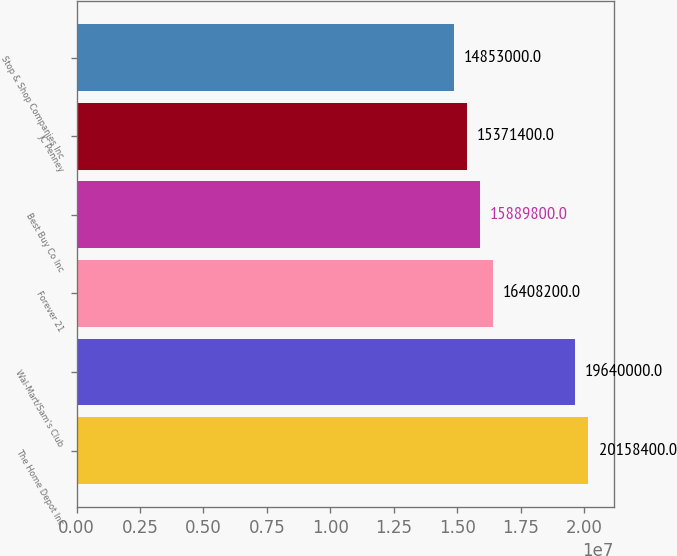<chart> <loc_0><loc_0><loc_500><loc_500><bar_chart><fcel>The Home Depot Inc<fcel>Wal-Mart/Sam's Club<fcel>Forever 21<fcel>Best Buy Co Inc<fcel>JC Penney<fcel>Stop & Shop Companies Inc<nl><fcel>2.01584e+07<fcel>1.964e+07<fcel>1.64082e+07<fcel>1.58898e+07<fcel>1.53714e+07<fcel>1.4853e+07<nl></chart> 